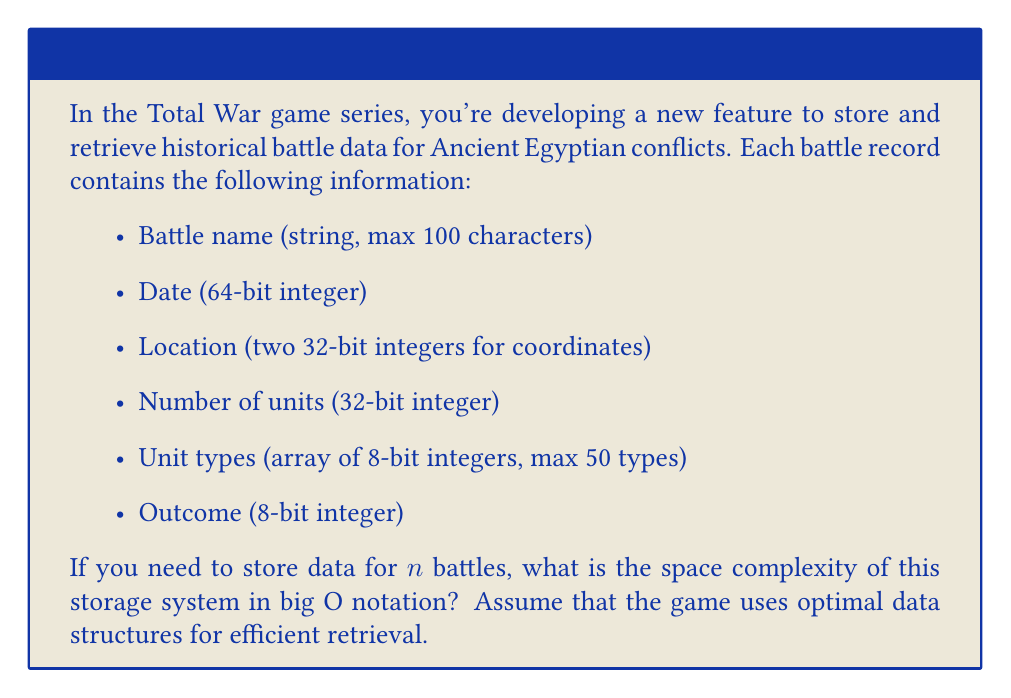Can you answer this question? Let's break down the space requirements for each component of a battle record:

1. Battle name: 100 characters * 1 byte per character = 100 bytes
2. Date: 64-bit integer = 8 bytes
3. Location: Two 32-bit integers = 2 * 4 bytes = 8 bytes
4. Number of units: 32-bit integer = 4 bytes
5. Unit types: Array of 8-bit integers, max 50 types = 50 * 1 byte = 50 bytes
6. Outcome: 8-bit integer = 1 byte

Total space for one battle record: 100 + 8 + 8 + 4 + 50 + 1 = 171 bytes

Now, we need to store this data for $n$ battles. The space required will be:

$$ \text{Total Space} = 171n \text{ bytes} $$

For efficient retrieval, we might use a hash table or a balanced search tree. These data structures typically have a constant factor overhead, but they don't change the overall space complexity.

In big O notation, we ignore constant factors. Therefore, the space complexity for storing $n$ battle records is $O(n)$.

It's worth noting that even if the number of unit types or the length of battle names were to increase with $n$, as long as they have a fixed upper bound (50 and 100 in this case), the space complexity would still be $O(n)$.
Answer: $O(n)$ 